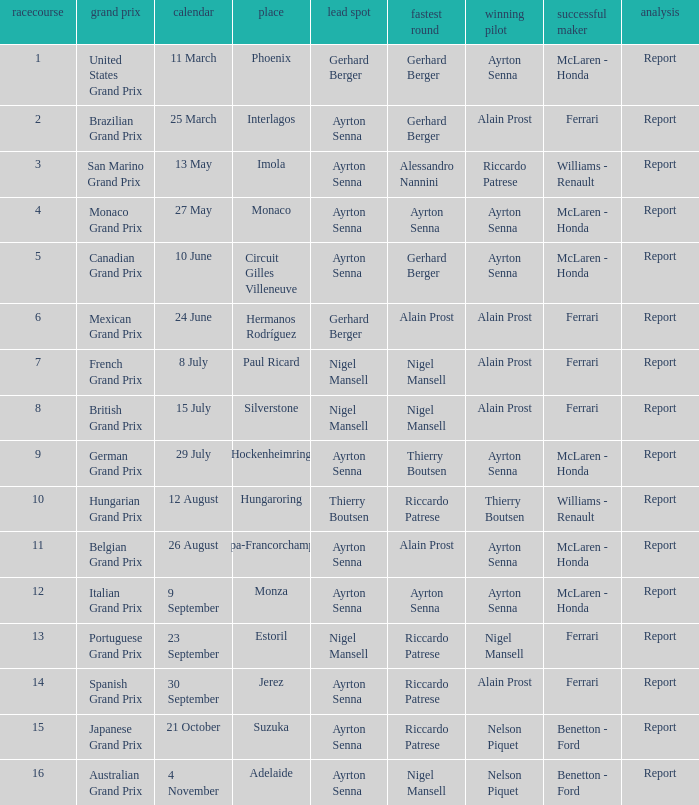What was the constructor when riccardo patrese was the winning driver? Williams - Renault. 